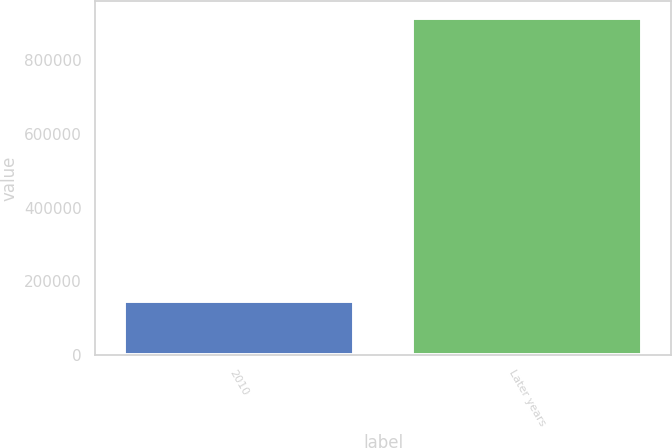<chart> <loc_0><loc_0><loc_500><loc_500><bar_chart><fcel>2010<fcel>Later years<nl><fcel>147241<fcel>915000<nl></chart> 